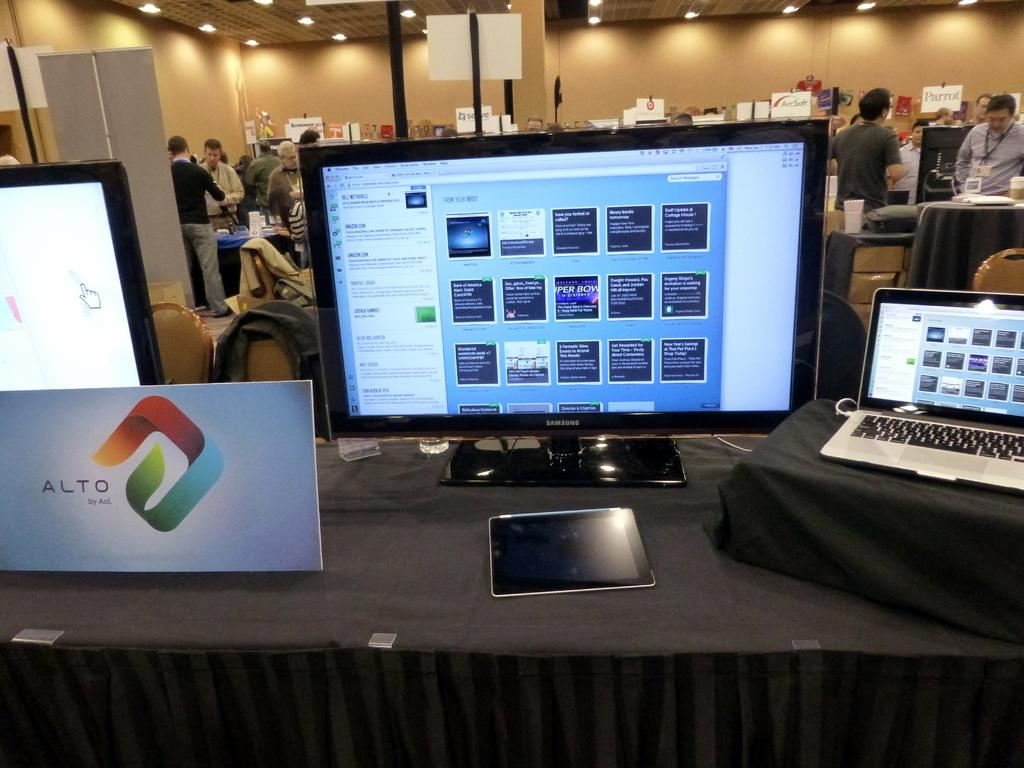Provide a one-sentence caption for the provided image. A monitor and laptop with a sign for Alto next to them. 